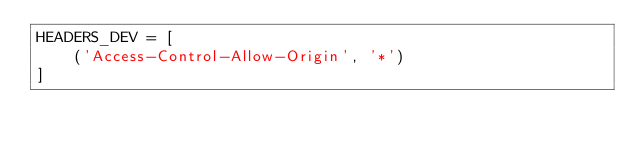Convert code to text. <code><loc_0><loc_0><loc_500><loc_500><_Python_>HEADERS_DEV = [
    ('Access-Control-Allow-Origin', '*')
]</code> 